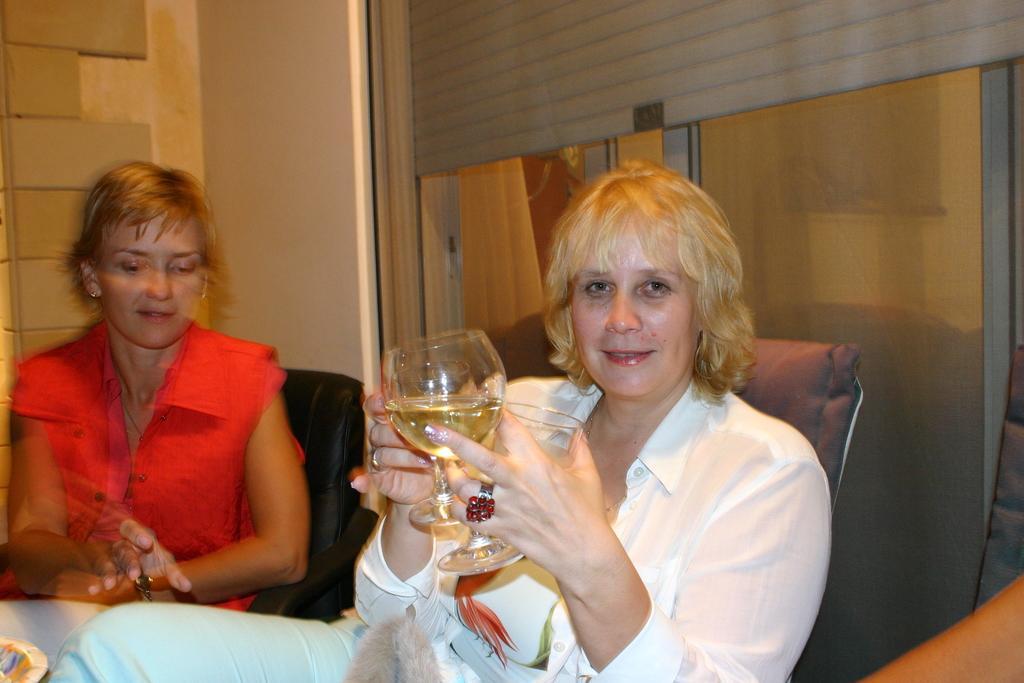Describe this image in one or two sentences. In this image there are two ladies. The lady in the middle wearing white shirt is holding two glasses is smiling. And the lady on the left she is wearing red. they both are sitting on chair. In the background there is a wall. 